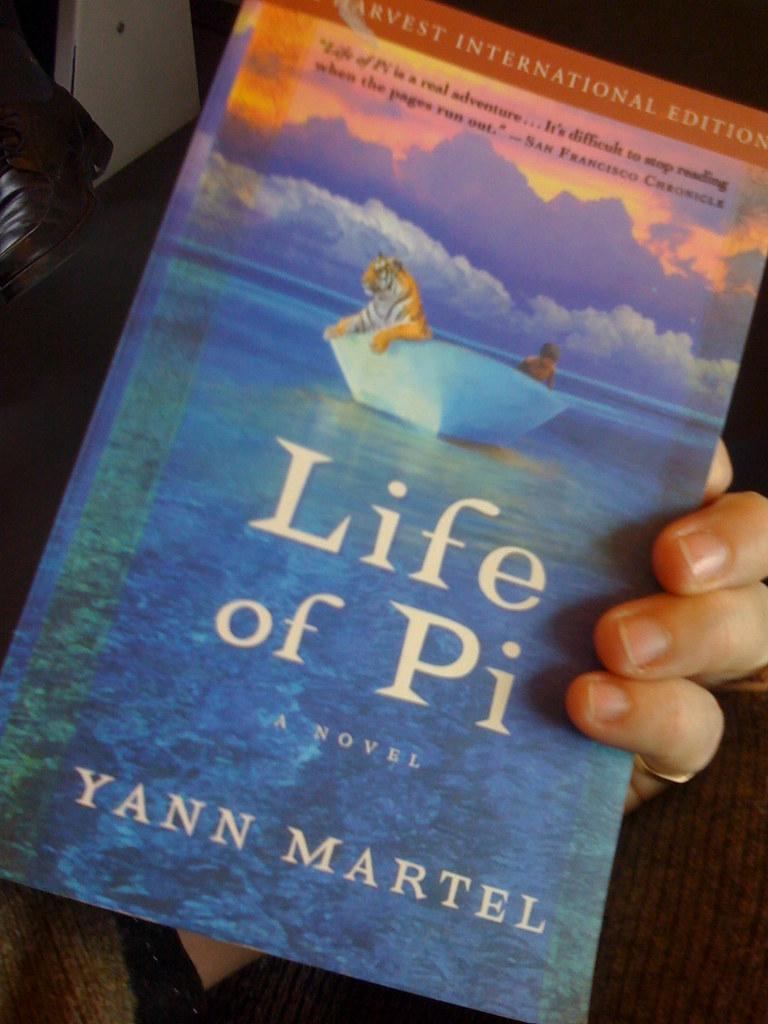What is the main subject of the image? There is a person in the image. What is the person holding in the image? The person is holding the Life of Pi novel. What type of apparel is the person wearing in the image? The provided facts do not mention any details about the person's apparel, so we cannot determine what type of clothing they are wearing. How many beans are visible in the image? There are no beans present in the image. 